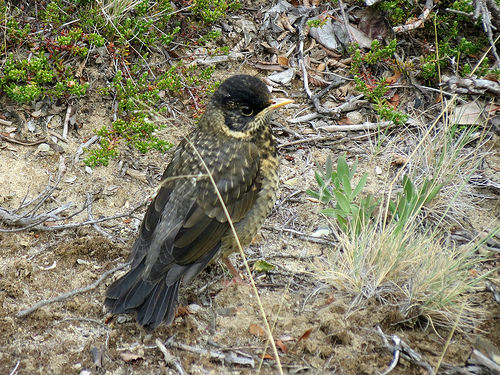<image>
Is there a ground on the bird? No. The ground is not positioned on the bird. They may be near each other, but the ground is not supported by or resting on top of the bird. 